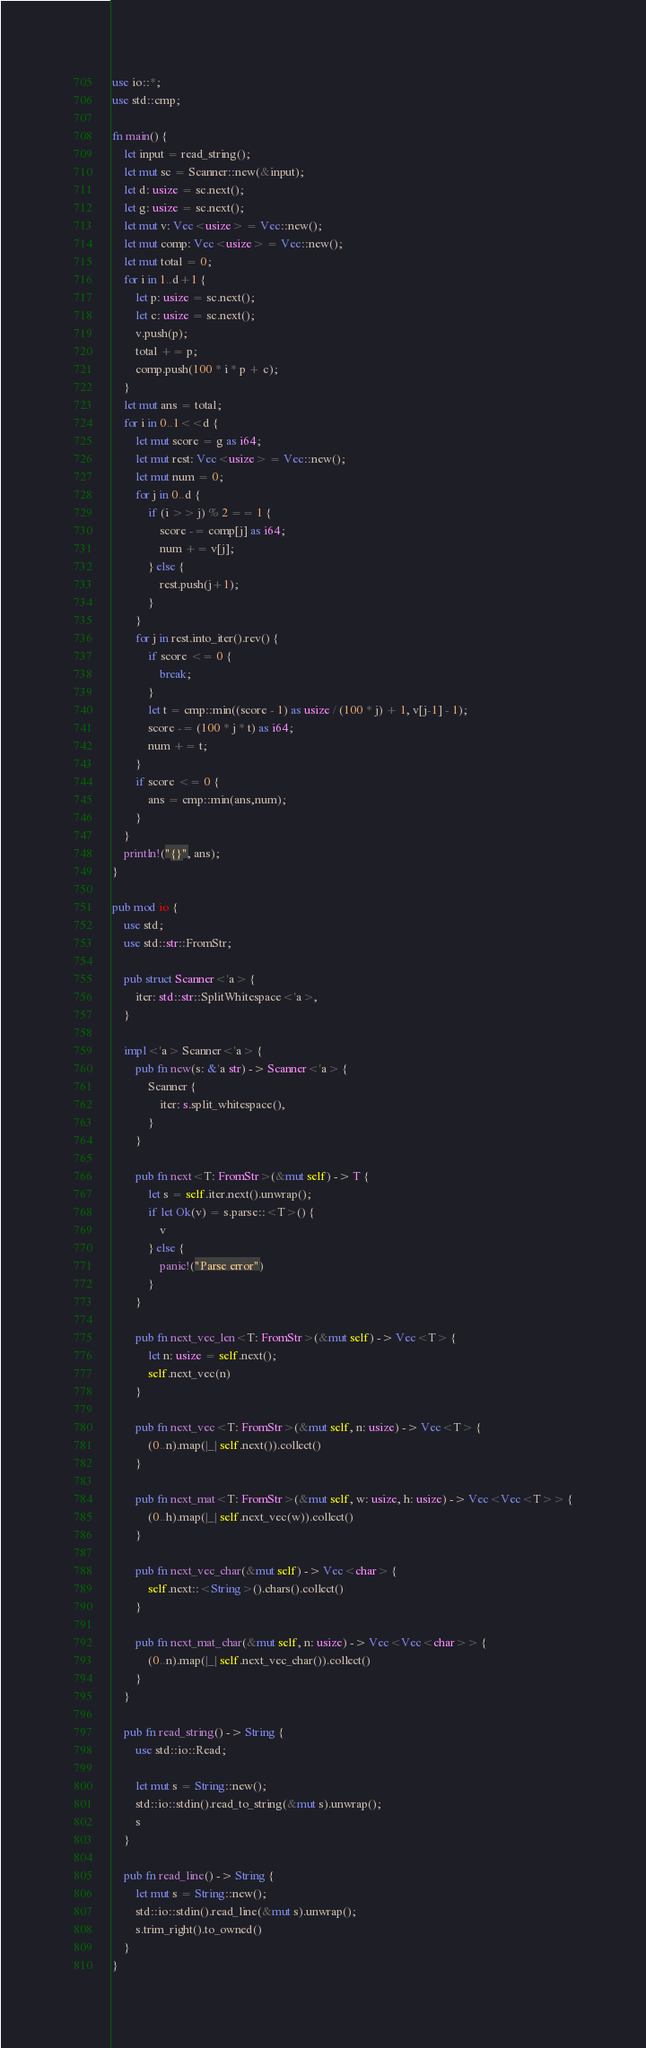Convert code to text. <code><loc_0><loc_0><loc_500><loc_500><_Rust_>use io::*;
use std::cmp;

fn main() {
    let input = read_string();
    let mut sc = Scanner::new(&input);
    let d: usize = sc.next();
    let g: usize = sc.next();
    let mut v: Vec<usize> = Vec::new();
    let mut comp: Vec<usize> = Vec::new();
    let mut total = 0;
    for i in 1..d+1 {
        let p: usize = sc.next();
        let c: usize = sc.next();
        v.push(p);
        total += p;
        comp.push(100 * i * p + c);
    }
    let mut ans = total;
    for i in 0..1<<d {
        let mut score = g as i64;
        let mut rest: Vec<usize> = Vec::new();
        let mut num = 0;
        for j in 0..d {
            if (i >> j) % 2 == 1 {
                score -= comp[j] as i64;
                num += v[j];
            } else {
                rest.push(j+1);
            }
        }
        for j in rest.into_iter().rev() {
            if score <= 0 {
                break;
            }
            let t = cmp::min((score - 1) as usize / (100 * j) + 1, v[j-1] - 1);
            score -= (100 * j * t) as i64;
            num += t;
        }
        if score <= 0 {
            ans = cmp::min(ans,num);
        }
    }
    println!("{}", ans);
}

pub mod io {
    use std;
    use std::str::FromStr;

    pub struct Scanner<'a> {
        iter: std::str::SplitWhitespace<'a>,
    }

    impl<'a> Scanner<'a> {
        pub fn new(s: &'a str) -> Scanner<'a> {
            Scanner {
                iter: s.split_whitespace(),
            }
        }

        pub fn next<T: FromStr>(&mut self) -> T {
            let s = self.iter.next().unwrap();
            if let Ok(v) = s.parse::<T>() {
                v
            } else {
                panic!("Parse error")
            }
        }

        pub fn next_vec_len<T: FromStr>(&mut self) -> Vec<T> {
            let n: usize = self.next();
            self.next_vec(n)
        }

        pub fn next_vec<T: FromStr>(&mut self, n: usize) -> Vec<T> {
            (0..n).map(|_| self.next()).collect()
        }

        pub fn next_mat<T: FromStr>(&mut self, w: usize, h: usize) -> Vec<Vec<T>> {
            (0..h).map(|_| self.next_vec(w)).collect()
        }

        pub fn next_vec_char(&mut self) -> Vec<char> {
            self.next::<String>().chars().collect()
        }

        pub fn next_mat_char(&mut self, n: usize) -> Vec<Vec<char>> {
            (0..n).map(|_| self.next_vec_char()).collect()
        }
    }

    pub fn read_string() -> String {
        use std::io::Read;

        let mut s = String::new();
        std::io::stdin().read_to_string(&mut s).unwrap();
        s
    }

    pub fn read_line() -> String {
        let mut s = String::new();
        std::io::stdin().read_line(&mut s).unwrap();
        s.trim_right().to_owned()
    }
}
</code> 